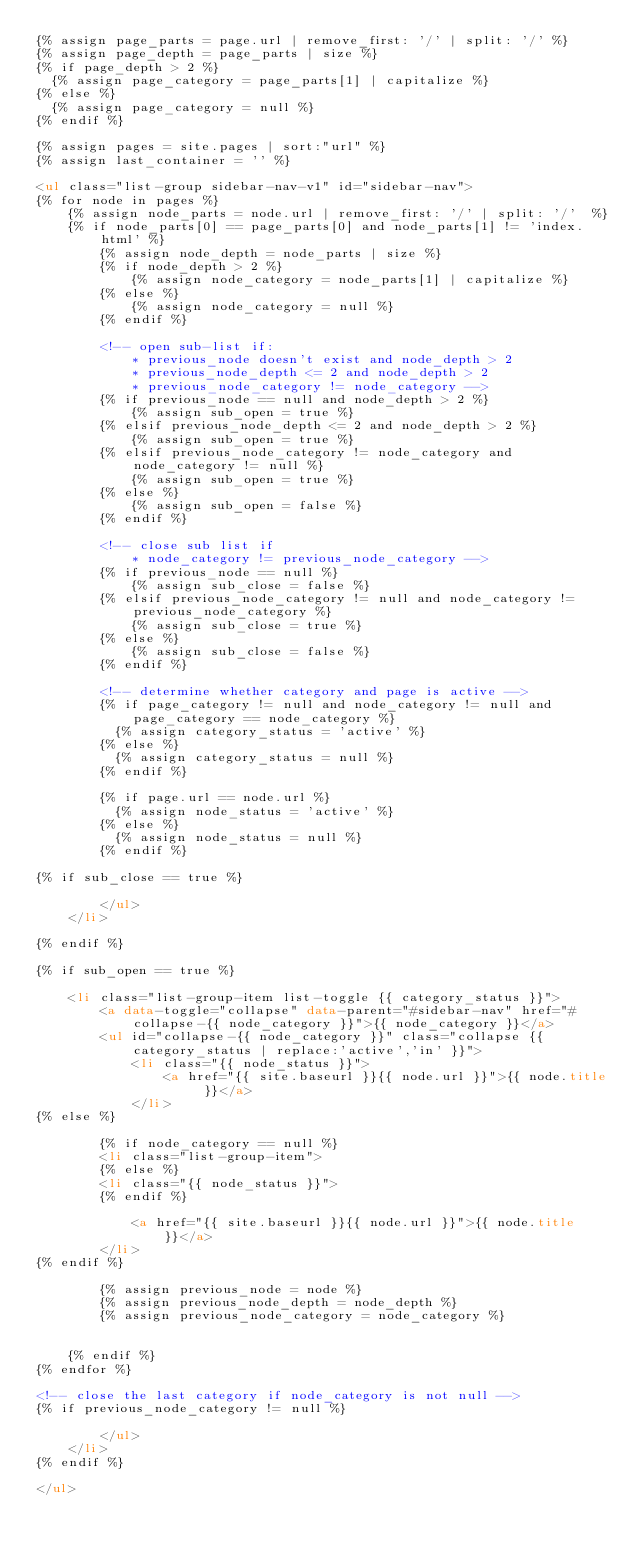<code> <loc_0><loc_0><loc_500><loc_500><_HTML_>{% assign page_parts = page.url | remove_first: '/' | split: '/' %}
{% assign page_depth = page_parts | size %}
{% if page_depth > 2 %}
  {% assign page_category = page_parts[1] | capitalize %}
{% else %}
  {% assign page_category = null %}
{% endif %}

{% assign pages = site.pages | sort:"url" %}
{% assign last_container = '' %}

<ul class="list-group sidebar-nav-v1" id="sidebar-nav">
{% for node in pages %}
    {% assign node_parts = node.url | remove_first: '/' | split: '/'  %}
    {% if node_parts[0] == page_parts[0] and node_parts[1] != 'index.html' %}
        {% assign node_depth = node_parts | size %}
        {% if node_depth > 2 %}
            {% assign node_category = node_parts[1] | capitalize %}
        {% else %}
            {% assign node_category = null %}
        {% endif %}

        <!-- open sub-list if:
            * previous_node doesn't exist and node_depth > 2
            * previous_node_depth <= 2 and node_depth > 2
            * previous_node_category != node_category -->
        {% if previous_node == null and node_depth > 2 %}
            {% assign sub_open = true %}
        {% elsif previous_node_depth <= 2 and node_depth > 2 %}
            {% assign sub_open = true %}
        {% elsif previous_node_category != node_category and node_category != null %}
            {% assign sub_open = true %}
        {% else %}
            {% assign sub_open = false %}
        {% endif %}

        <!-- close sub list if
            * node_category != previous_node_category -->
        {% if previous_node == null %}
            {% assign sub_close = false %}
        {% elsif previous_node_category != null and node_category != previous_node_category %}
            {% assign sub_close = true %}
        {% else %}
            {% assign sub_close = false %}
        {% endif %}

        <!-- determine whether category and page is active -->
        {% if page_category != null and node_category != null and page_category == node_category %}
          {% assign category_status = 'active' %}
        {% else %}
          {% assign category_status = null %}
        {% endif %}

        {% if page.url == node.url %}
          {% assign node_status = 'active' %}
        {% else %}
          {% assign node_status = null %}
        {% endif %}

{% if sub_close == true %}

        </ul>
    </li>

{% endif %}

{% if sub_open == true %}

    <li class="list-group-item list-toggle {{ category_status }}">
        <a data-toggle="collapse" data-parent="#sidebar-nav" href="#collapse-{{ node_category }}">{{ node_category }}</a>
        <ul id="collapse-{{ node_category }}" class="collapse {{ category_status | replace:'active','in' }}">
            <li class="{{ node_status }}">
                <a href="{{ site.baseurl }}{{ node.url }}">{{ node.title }}</a>
            </li>
{% else %}

        {% if node_category == null %}
        <li class="list-group-item">
        {% else %}
        <li class="{{ node_status }}">
        {% endif %}

            <a href="{{ site.baseurl }}{{ node.url }}">{{ node.title }}</a>
        </li>
{% endif %}

        {% assign previous_node = node %}
        {% assign previous_node_depth = node_depth %}
        {% assign previous_node_category = node_category %}


    {% endif %}
{% endfor %}

<!-- close the last category if node_category is not null -->
{% if previous_node_category != null %}

        </ul>
    </li>
{% endif %}

</ul>
</code> 